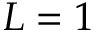<formula> <loc_0><loc_0><loc_500><loc_500>L = 1</formula> 